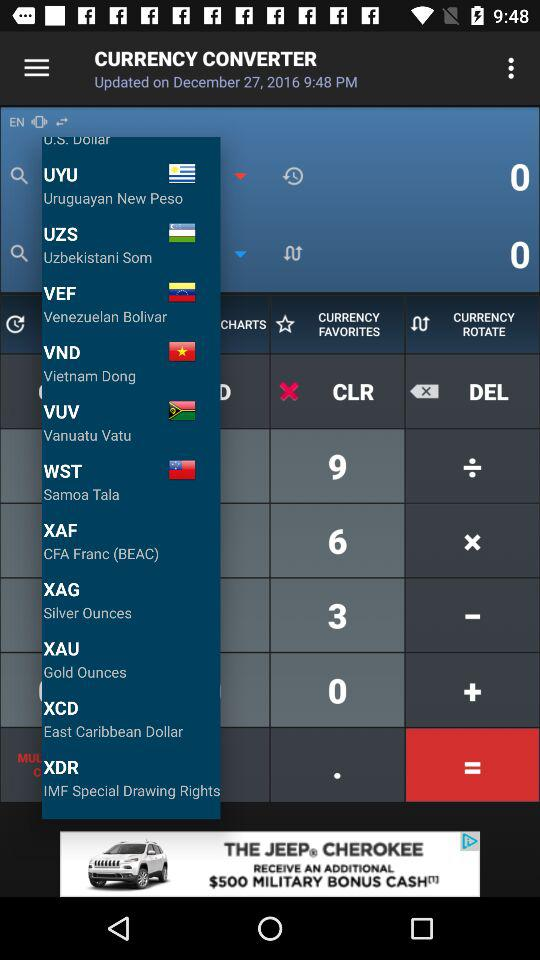Which country does the Venezuelan Bolivar belong to? The Venezuelan Bolivar belongs to Venezuela. 